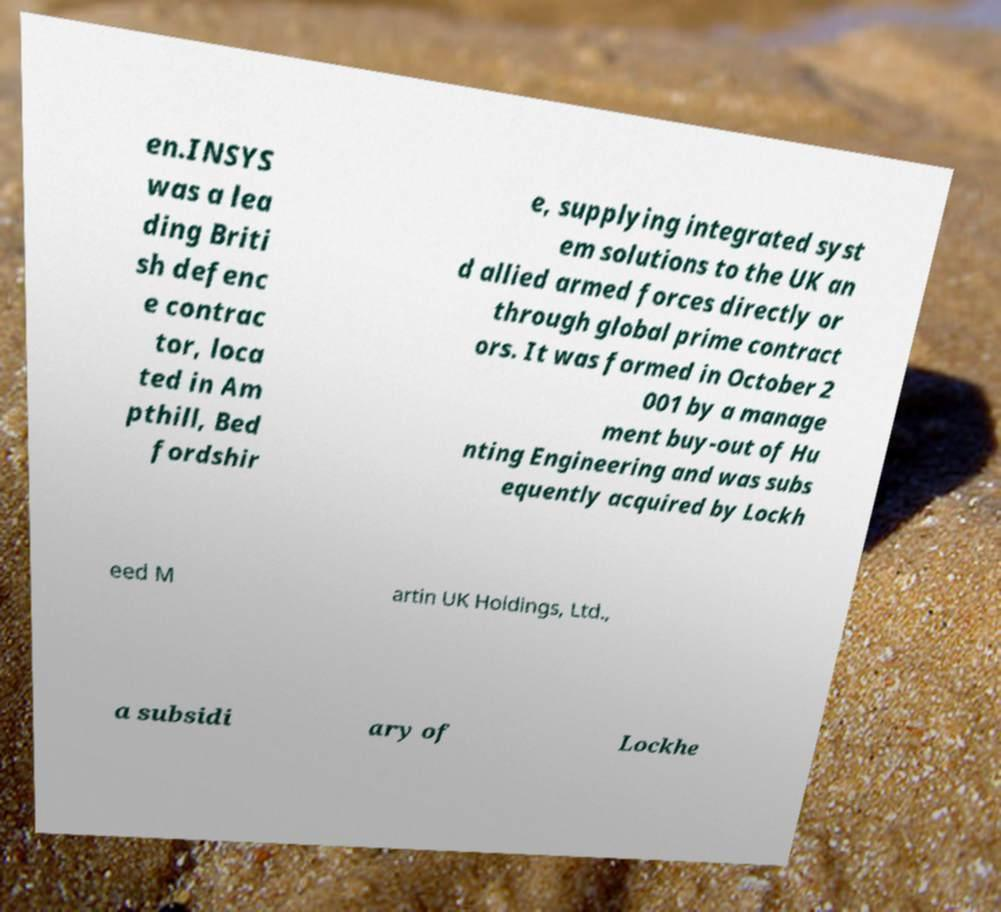I need the written content from this picture converted into text. Can you do that? en.INSYS was a lea ding Briti sh defenc e contrac tor, loca ted in Am pthill, Bed fordshir e, supplying integrated syst em solutions to the UK an d allied armed forces directly or through global prime contract ors. It was formed in October 2 001 by a manage ment buy-out of Hu nting Engineering and was subs equently acquired by Lockh eed M artin UK Holdings, Ltd., a subsidi ary of Lockhe 